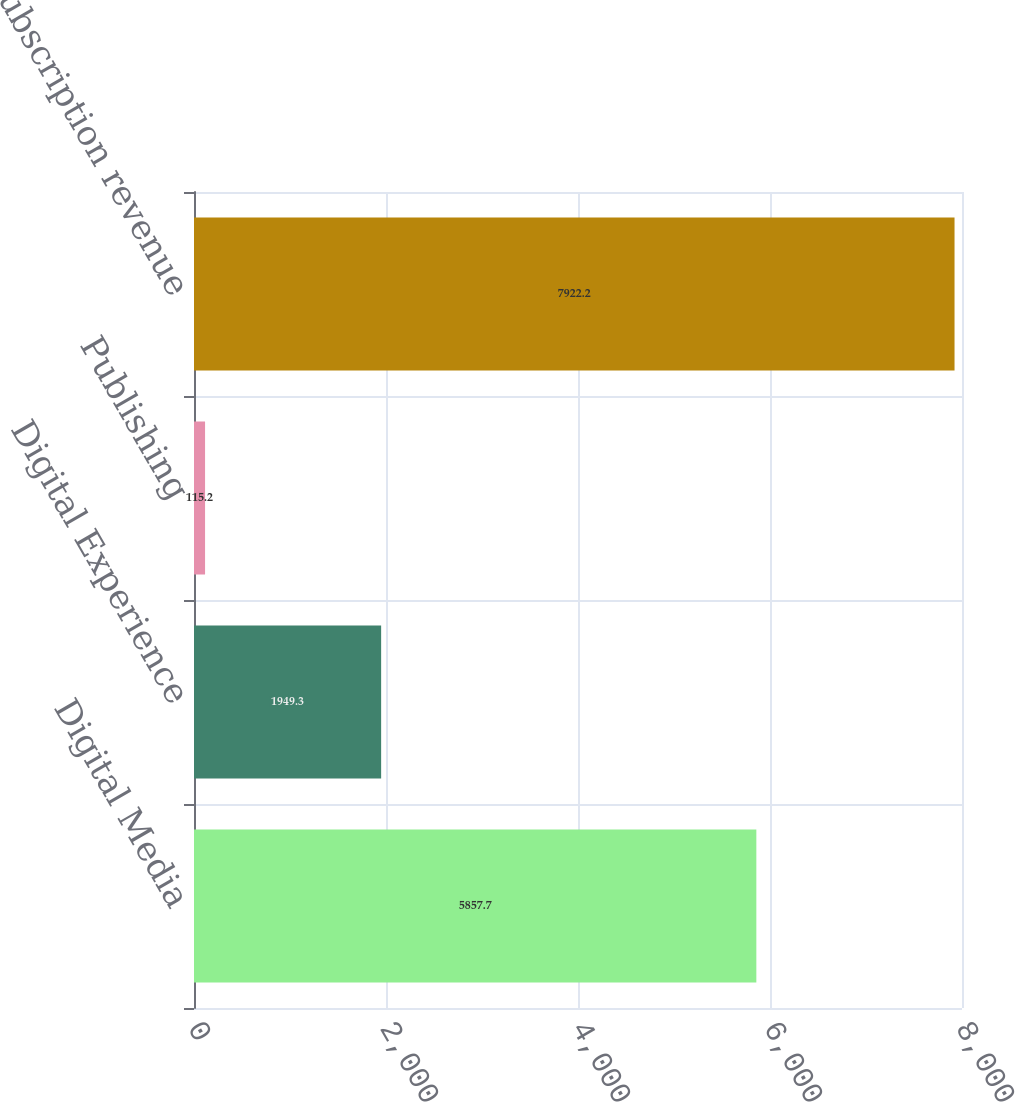<chart> <loc_0><loc_0><loc_500><loc_500><bar_chart><fcel>Digital Media<fcel>Digital Experience<fcel>Publishing<fcel>Total subscription revenue<nl><fcel>5857.7<fcel>1949.3<fcel>115.2<fcel>7922.2<nl></chart> 